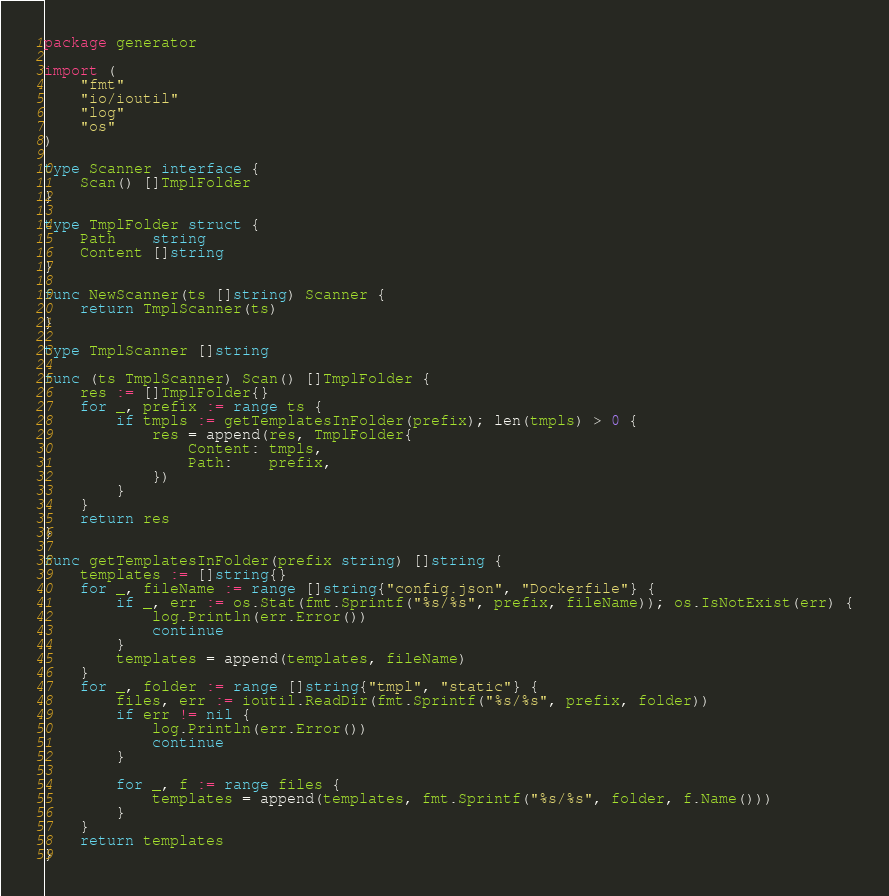Convert code to text. <code><loc_0><loc_0><loc_500><loc_500><_Go_>package generator

import (
	"fmt"
	"io/ioutil"
	"log"
	"os"
)

type Scanner interface {
	Scan() []TmplFolder
}

type TmplFolder struct {
	Path    string
	Content []string
}

func NewScanner(ts []string) Scanner {
	return TmplScanner(ts)
}

type TmplScanner []string

func (ts TmplScanner) Scan() []TmplFolder {
	res := []TmplFolder{}
	for _, prefix := range ts {
		if tmpls := getTemplatesInFolder(prefix); len(tmpls) > 0 {
			res = append(res, TmplFolder{
				Content: tmpls,
				Path:    prefix,
			})
		}
	}
	return res
}

func getTemplatesInFolder(prefix string) []string {
	templates := []string{}
	for _, fileName := range []string{"config.json", "Dockerfile"} {
		if _, err := os.Stat(fmt.Sprintf("%s/%s", prefix, fileName)); os.IsNotExist(err) {
			log.Println(err.Error())
			continue
		}
		templates = append(templates, fileName)
	}
	for _, folder := range []string{"tmpl", "static"} {
		files, err := ioutil.ReadDir(fmt.Sprintf("%s/%s", prefix, folder))
		if err != nil {
			log.Println(err.Error())
			continue
		}

		for _, f := range files {
			templates = append(templates, fmt.Sprintf("%s/%s", folder, f.Name()))
		}
	}
	return templates
}
</code> 